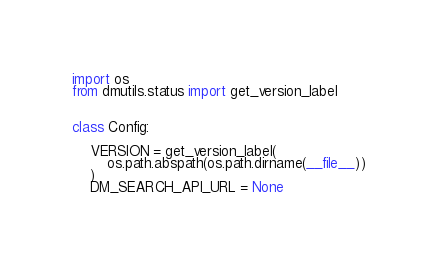Convert code to text. <code><loc_0><loc_0><loc_500><loc_500><_Python_>import os
from dmutils.status import get_version_label


class Config:

    VERSION = get_version_label(
        os.path.abspath(os.path.dirname(__file__))
    )
    DM_SEARCH_API_URL = None</code> 